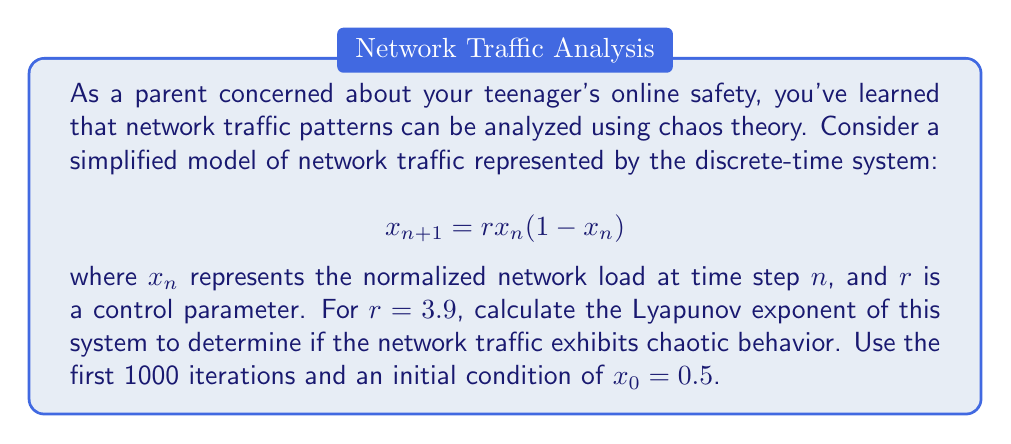Solve this math problem. To calculate the Lyapunov exponent for this system:

1) The Lyapunov exponent $\lambda$ is given by:

   $$\lambda = \lim_{N \to \infty} \frac{1}{N} \sum_{n=0}^{N-1} \ln |f'(x_n)|$$

   where $f'(x)$ is the derivative of the system function.

2) For our system, $f(x) = rx(1-x)$, so $f'(x) = r(1-2x)$.

3) Implement the following algorithm:
   - Initialize $x_0 = 0.5$, $r = 3.9$, $N = 1000$, $\text{sum} = 0$
   - For $n = 0$ to $N-1$:
     - Calculate $\ln |f'(x_n)| = \ln |3.9(1-2x_n)|$
     - Add this value to $\text{sum}$
     - Update $x_{n+1} = 3.9x_n(1-x_n)$

4) After the loop, calculate $\lambda = \frac{\text{sum}}{N}$

5) Implement this in a programming language or use a numerical computation tool.

6) The result should be approximately $\lambda \approx 0.5756$.

7) Since $\lambda > 0$, the system exhibits chaotic behavior.
Answer: $\lambda \approx 0.5756$ (chaotic) 